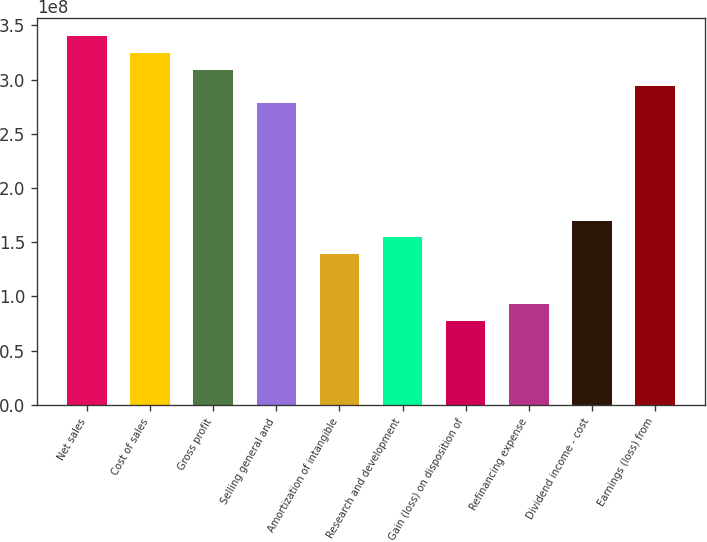Convert chart to OTSL. <chart><loc_0><loc_0><loc_500><loc_500><bar_chart><fcel>Net sales<fcel>Cost of sales<fcel>Gross profit<fcel>Selling general and<fcel>Amortization of intangible<fcel>Research and development<fcel>Gain (loss) on disposition of<fcel>Refinancing expense<fcel>Dividend income - cost<fcel>Earnings (loss) from<nl><fcel>3.40041e+08<fcel>3.24585e+08<fcel>3.09128e+08<fcel>2.78215e+08<fcel>1.39108e+08<fcel>1.54564e+08<fcel>7.72821e+07<fcel>9.27385e+07<fcel>1.70021e+08<fcel>2.93672e+08<nl></chart> 